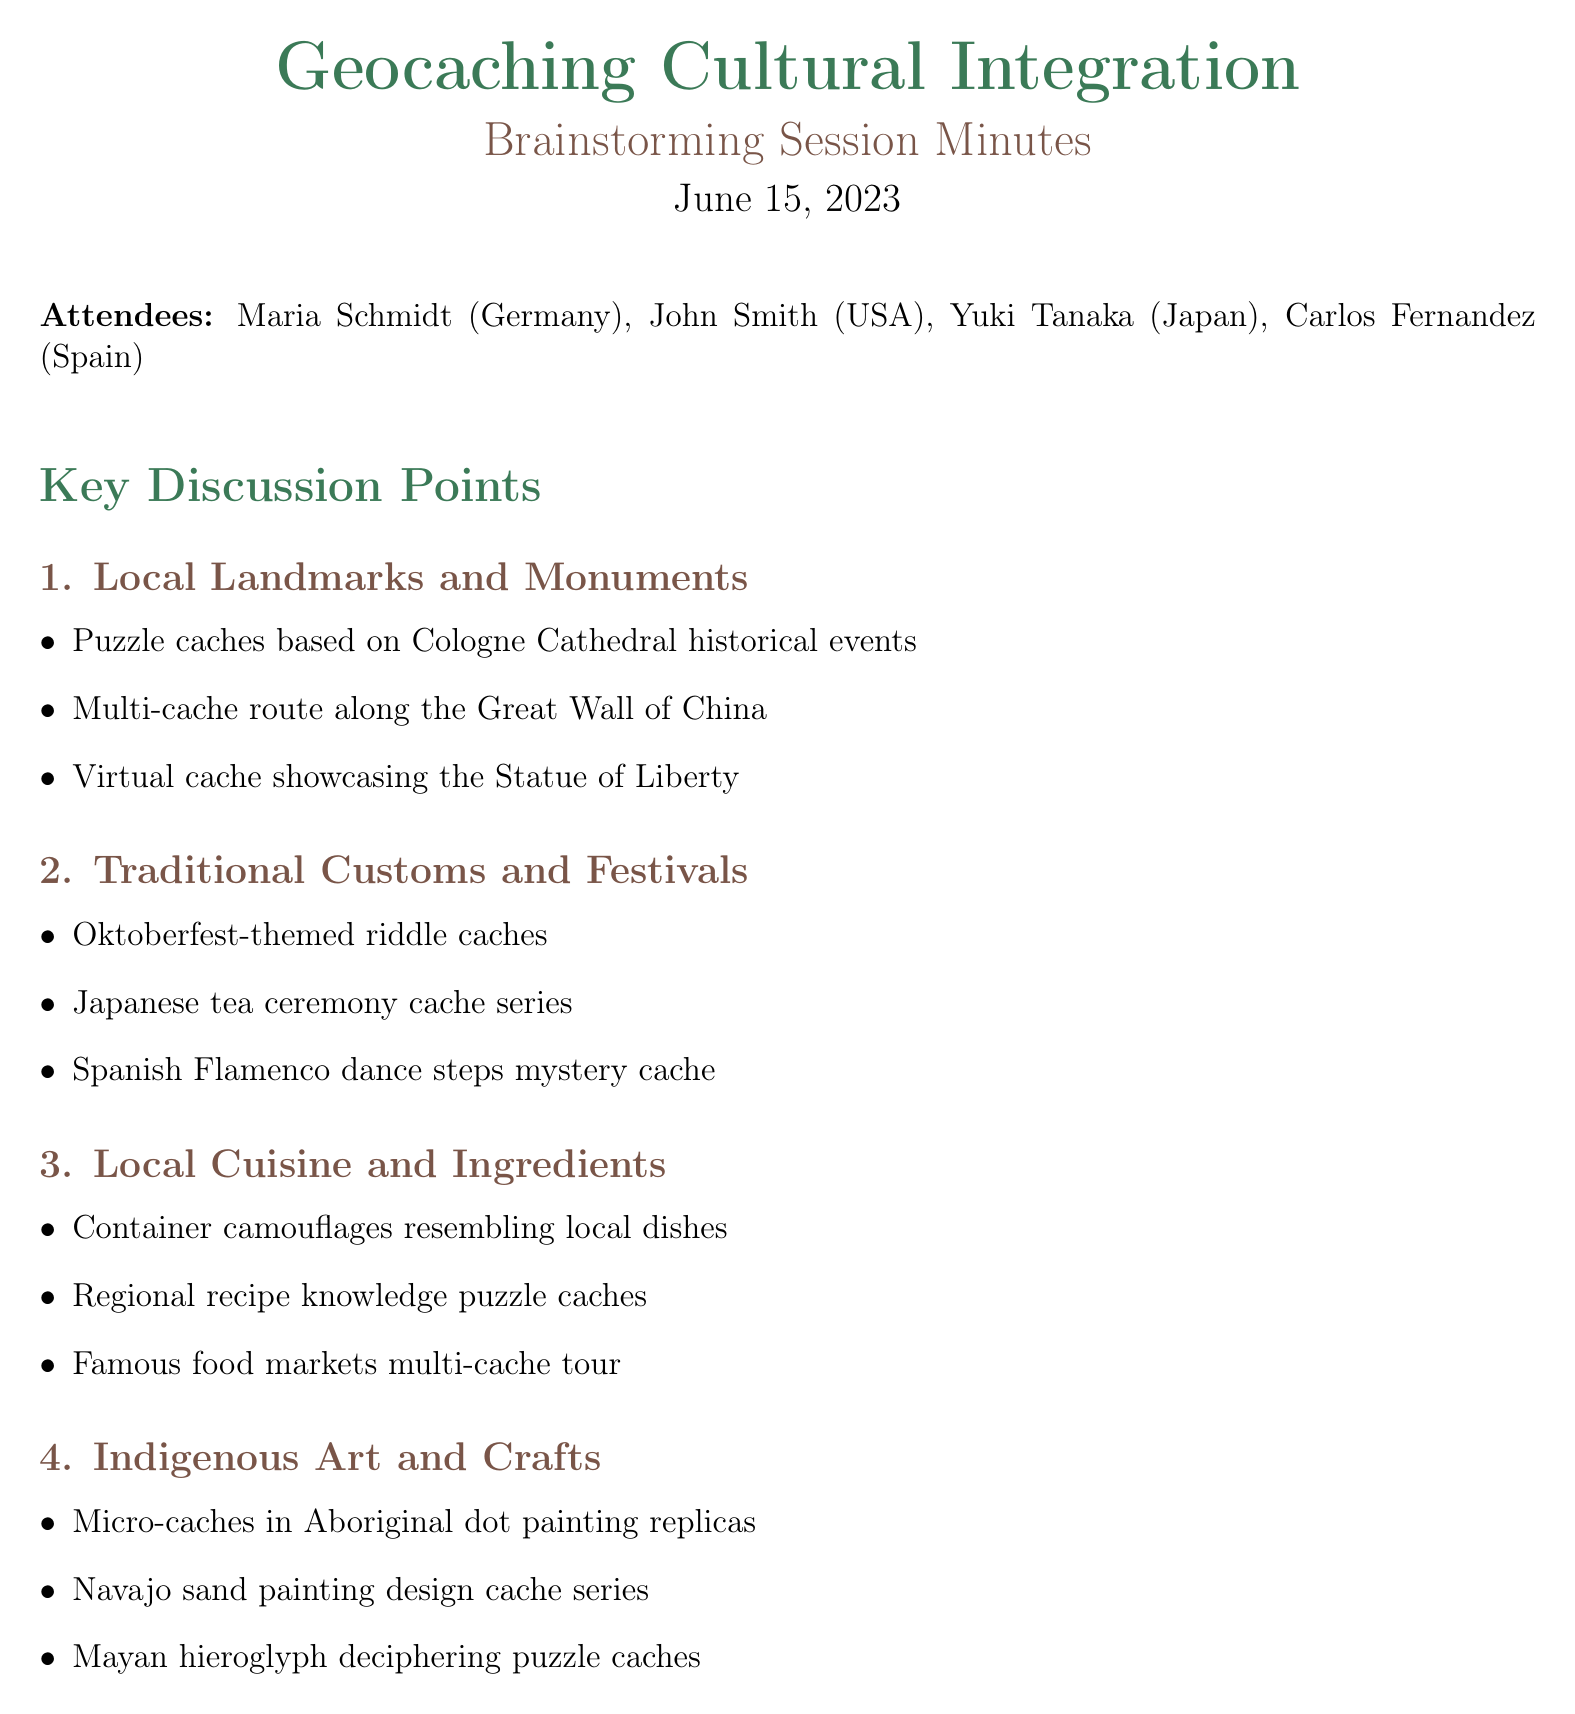What was the date of the meeting? The date of the meeting is explicitly mentioned in the document heading.
Answer: June 15, 2023 Who attended from Japan? The attendees list includes individual names and their respective countries.
Answer: Yuki Tanaka What is one idea for traditional customs and festivals? Multiple ideas are listed under the corresponding topic; one of them will answer this question.
Answer: Hide caches with riddles related to Oktoberfest traditions How many action items were discussed? The section on action items lists specific tasks, which can be counted for the total.
Answer: Four What is the next meeting date? The next meeting date is provided near the end of the document.
Answer: July 1, 2023 Which cultural element is related to local cuisine? The document mentions different cultural aspects; identifying one under the local cuisine section answers the question.
Answer: Container camouflages resembling local dishes What type of cache is suggested for the Statue of Liberty? The type of cache is specified along with its related cultural landmark in the ideas section.
Answer: Virtual cache Which landmark is associated with a multi-cache route idea? The document lists specific ideas under local landmarks, allowing for location identification.
Answer: Great Wall of China 